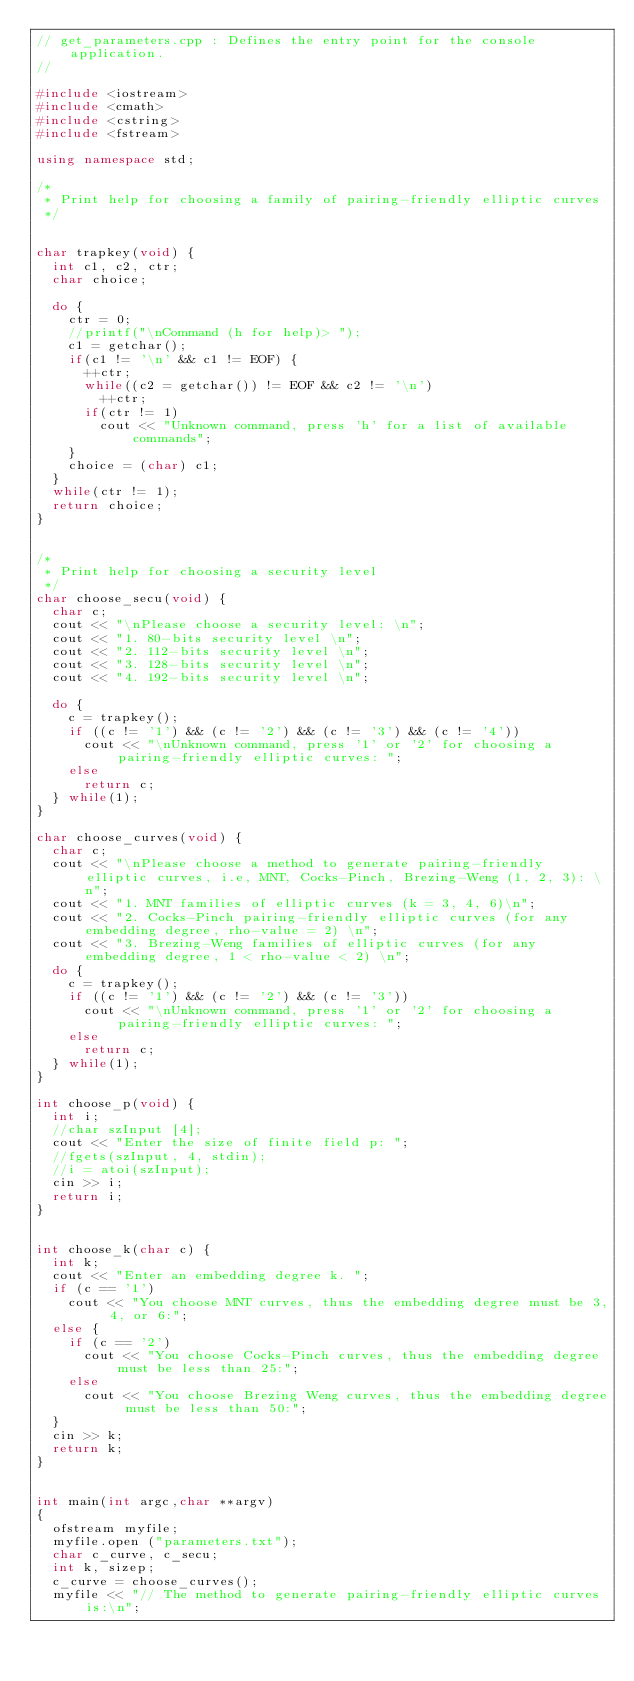<code> <loc_0><loc_0><loc_500><loc_500><_C++_>// get_parameters.cpp : Defines the entry point for the console application.
//

#include <iostream>
#include <cmath>
#include <cstring>
#include <fstream>

using namespace std;

/*
 * Print help for choosing a family of pairing-friendly elliptic curves
 */


char trapkey(void) {
	int c1, c2, ctr;
	char choice;

	do {
		ctr = 0;
		//printf("\nCommand (h for help)> ");
		c1 = getchar();
		if(c1 != '\n' && c1 != EOF) {
			++ctr;
			while((c2 = getchar()) != EOF && c2 != '\n')
				++ctr;
			if(ctr != 1)
				cout << "Unknown command, press 'h' for a list of available commands";
		}
		choice = (char) c1;
	}
	while(ctr != 1);
	return choice;
}


/*
 * Print help for choosing a security level
 */
char choose_secu(void) {
	char c;
	cout << "\nPlease choose a security level: \n";
	cout << "1. 80-bits security level \n";
	cout << "2. 112-bits security level \n";
	cout << "3. 128-bits security level \n";
	cout << "4. 192-bits security level \n";
	
	do {
		c = trapkey();
		if ((c != '1') && (c != '2') && (c != '3') && (c != '4'))
			cout << "\nUnknown command, press '1' or '2' for choosing a pairing-friendly elliptic curves: ";
		else 
			return c;
	} while(1);	
}

char choose_curves(void) {
	char c;
	cout << "\nPlease choose a method to generate pairing-friendly elliptic curves, i.e, MNT, Cocks-Pinch, Brezing-Weng (1, 2, 3): \n";
	cout << "1. MNT families of elliptic curves (k = 3, 4, 6)\n";
	cout << "2. Cocks-Pinch pairing-friendly elliptic curves (for any embedding degree, rho-value = 2) \n";
	cout << "3. Brezing-Weng families of elliptic curves (for any embedding degree, 1 < rho-value < 2) \n";
	do {
		c = trapkey();
		if ((c != '1') && (c != '2') && (c != '3'))
			cout << "\nUnknown command, press '1' or '2' for choosing a pairing-friendly elliptic curves: ";
		else 
			return c;
	} while(1);	
}

int choose_p(void) {
	int i;
	//char szInput [4];
	cout << "Enter the size of finite field p: ";
	//fgets(szInput, 4, stdin);
	//i = atoi(szInput);
	cin >> i;
  return i;
}


int choose_k(char c) {
	int k;
	cout << "Enter an embedding degree k. ";
	if (c == '1') 
		cout << "You choose MNT curves, thus the embedding degree must be 3, 4, or 6:";
	else { 
		if (c == '2')
			cout << "You choose Cocks-Pinch curves, thus the embedding degree must be less than 25:";
		else
			cout << "You choose Brezing Weng curves, thus the embedding degree must be less than 50:";
	}
	cin >> k;
  return k;
}


int main(int argc,char **argv)
{
	ofstream myfile;
	myfile.open ("parameters.txt");
	char c_curve, c_secu;
	int k, sizep;
	c_curve = choose_curves();
	myfile << "// The method to generate pairing-friendly elliptic curves is:\n";</code> 